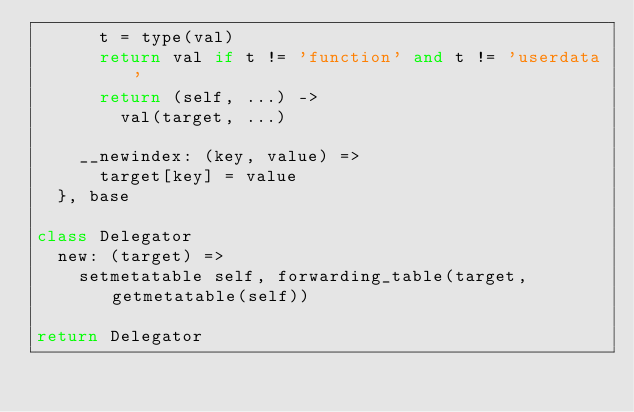<code> <loc_0><loc_0><loc_500><loc_500><_MoonScript_>      t = type(val)
      return val if t != 'function' and t != 'userdata'
      return (self, ...) ->
        val(target, ...)

    __newindex: (key, value) =>
      target[key] = value
  }, base

class Delegator
  new: (target) =>
    setmetatable self, forwarding_table(target, getmetatable(self))

return Delegator
</code> 